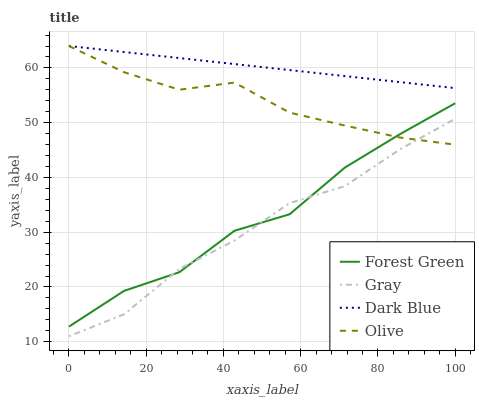Does Gray have the minimum area under the curve?
Answer yes or no. Yes. Does Dark Blue have the maximum area under the curve?
Answer yes or no. Yes. Does Forest Green have the minimum area under the curve?
Answer yes or no. No. Does Forest Green have the maximum area under the curve?
Answer yes or no. No. Is Dark Blue the smoothest?
Answer yes or no. Yes. Is Forest Green the roughest?
Answer yes or no. Yes. Is Gray the smoothest?
Answer yes or no. No. Is Gray the roughest?
Answer yes or no. No. Does Gray have the lowest value?
Answer yes or no. Yes. Does Forest Green have the lowest value?
Answer yes or no. No. Does Dark Blue have the highest value?
Answer yes or no. Yes. Does Forest Green have the highest value?
Answer yes or no. No. Is Gray less than Dark Blue?
Answer yes or no. Yes. Is Dark Blue greater than Gray?
Answer yes or no. Yes. Does Olive intersect Forest Green?
Answer yes or no. Yes. Is Olive less than Forest Green?
Answer yes or no. No. Is Olive greater than Forest Green?
Answer yes or no. No. Does Gray intersect Dark Blue?
Answer yes or no. No. 